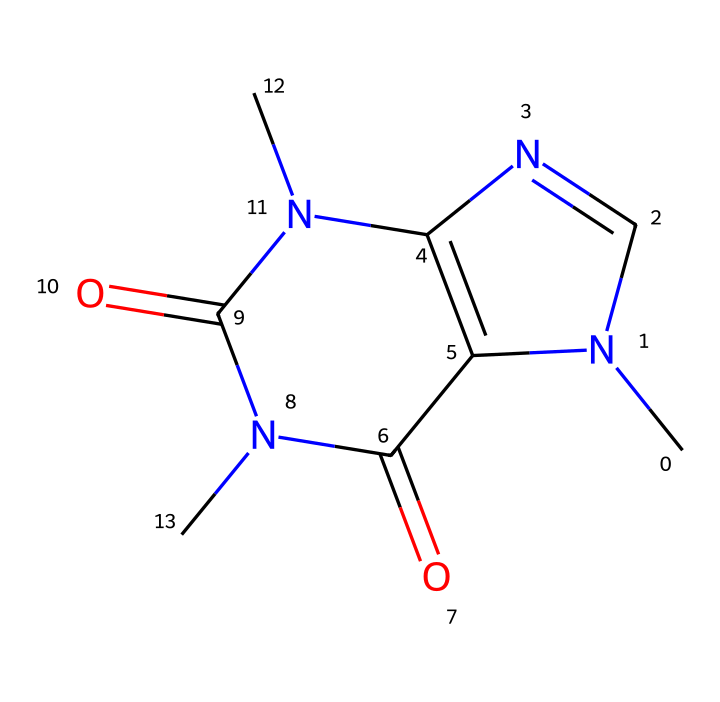What is the molecular formula of caffeine? The molecular formula can be derived from the SMILES representation by identifying the different atoms present. Count the carbon, hydrogen, nitrogen, and oxygen atoms. There are 8 carbon (C), 10 hydrogen (H), 4 nitrogen (N), and 2 oxygen (O) atoms, yielding the formula C8H10N4O2.
Answer: C8H10N4O2 How many nitrogen atoms are present in caffeine? By analyzing the SMILES representation, we locate the nitrogen (N) symbols. There are 4 instances of nitrogen present within the compound.
Answer: 4 Is caffeine an aliphatic compound? Caffeine contains a cyclic structure in its chemical representation, indicating it has aromatic characteristics rather than being purely aliphatic. Therefore, it is not categorized as an aliphatic compound.
Answer: No What type of bonding occurs between the atoms in caffeine? The structure consists mainly of single (sigma) and double bonds. This can be confirmed by examining the connections between atoms in the SMILES. Double bonds are primarily seen between carbon and oxygen, and certain carbon-nitrogen connections are highlighted.
Answer: Single and double bonds What is the functional group present in caffeine that indicates it's an aromatic compound? The presence of nitrogen atoms in a ring structure in combination with carbon atoms indicates aromaticity. The cyclic nature and nitrogen's participation in the ring system suggest it has an aromatic character.
Answer: Aromatic ring How does the structure of caffeine contribute to its stimulant properties? The nitrogen atoms, which are found in a configuration typical of xanthine derivatives, contribute to the stimulant effect, as they interact with adenosine receptors in the brain, promoting wakefulness. This relationship between structure and biological activity highlights how the specific arrangement of nitrogen atoms is essential for its functionality as a stimulant.
Answer: Nitrogen atoms 